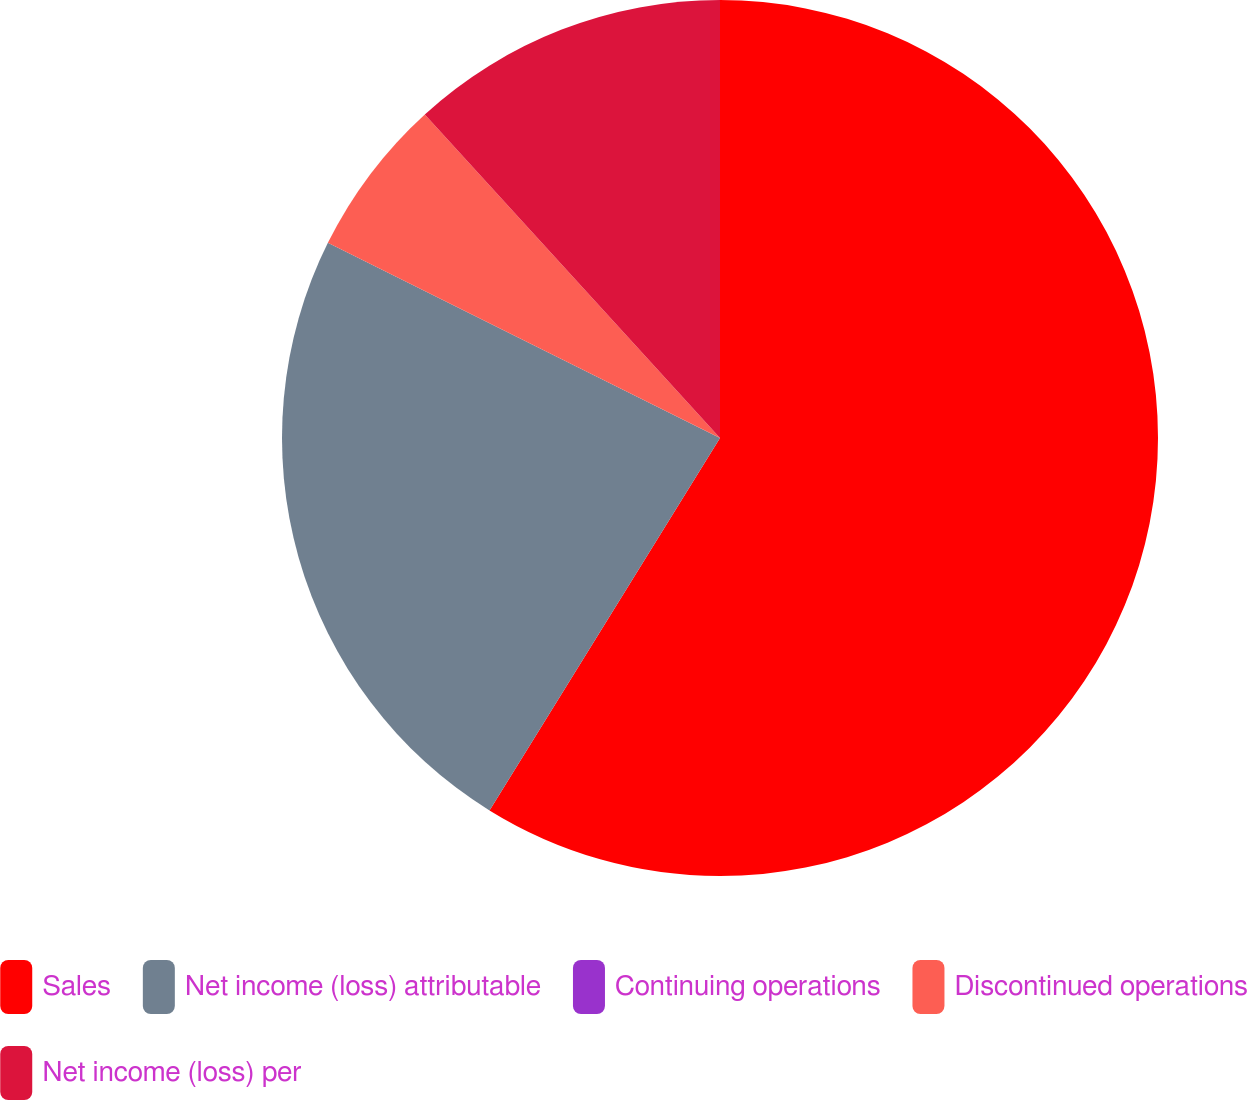<chart> <loc_0><loc_0><loc_500><loc_500><pie_chart><fcel>Sales<fcel>Net income (loss) attributable<fcel>Continuing operations<fcel>Discontinued operations<fcel>Net income (loss) per<nl><fcel>58.82%<fcel>23.53%<fcel>0.0%<fcel>5.88%<fcel>11.77%<nl></chart> 